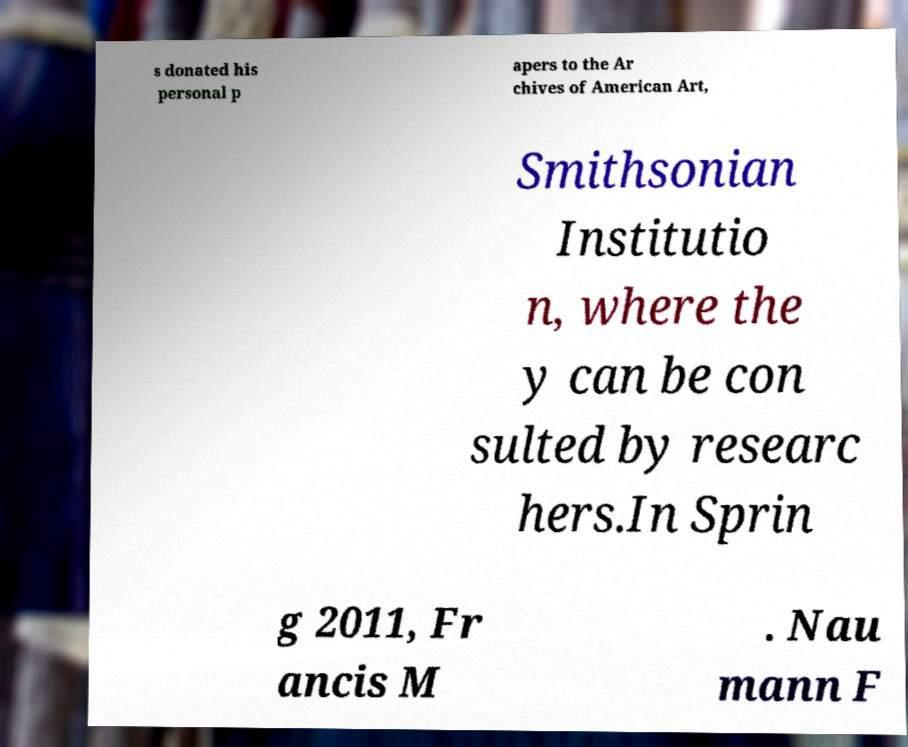Please identify and transcribe the text found in this image. s donated his personal p apers to the Ar chives of American Art, Smithsonian Institutio n, where the y can be con sulted by researc hers.In Sprin g 2011, Fr ancis M . Nau mann F 